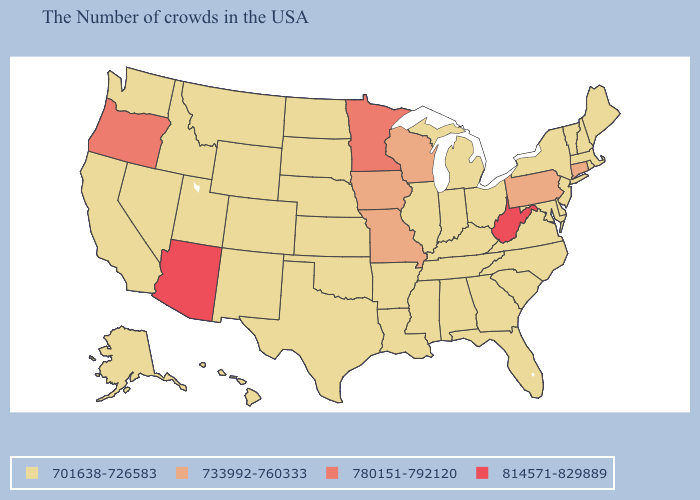What is the highest value in the South ?
Quick response, please. 814571-829889. Which states have the lowest value in the South?
Short answer required. Delaware, Maryland, Virginia, North Carolina, South Carolina, Florida, Georgia, Kentucky, Alabama, Tennessee, Mississippi, Louisiana, Arkansas, Oklahoma, Texas. Among the states that border North Carolina , which have the lowest value?
Write a very short answer. Virginia, South Carolina, Georgia, Tennessee. Among the states that border Massachusetts , which have the highest value?
Concise answer only. Connecticut. Does West Virginia have the highest value in the USA?
Answer briefly. Yes. What is the value of Montana?
Short answer required. 701638-726583. Name the states that have a value in the range 780151-792120?
Be succinct. Minnesota, Oregon. What is the lowest value in the MidWest?
Give a very brief answer. 701638-726583. How many symbols are there in the legend?
Be succinct. 4. What is the value of Illinois?
Keep it brief. 701638-726583. How many symbols are there in the legend?
Answer briefly. 4. Does Montana have the highest value in the West?
Give a very brief answer. No. Name the states that have a value in the range 701638-726583?
Give a very brief answer. Maine, Massachusetts, Rhode Island, New Hampshire, Vermont, New York, New Jersey, Delaware, Maryland, Virginia, North Carolina, South Carolina, Ohio, Florida, Georgia, Michigan, Kentucky, Indiana, Alabama, Tennessee, Illinois, Mississippi, Louisiana, Arkansas, Kansas, Nebraska, Oklahoma, Texas, South Dakota, North Dakota, Wyoming, Colorado, New Mexico, Utah, Montana, Idaho, Nevada, California, Washington, Alaska, Hawaii. What is the value of Kansas?
Short answer required. 701638-726583. Which states have the highest value in the USA?
Keep it brief. West Virginia, Arizona. 